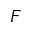Convert formula to latex. <formula><loc_0><loc_0><loc_500><loc_500>F</formula> 